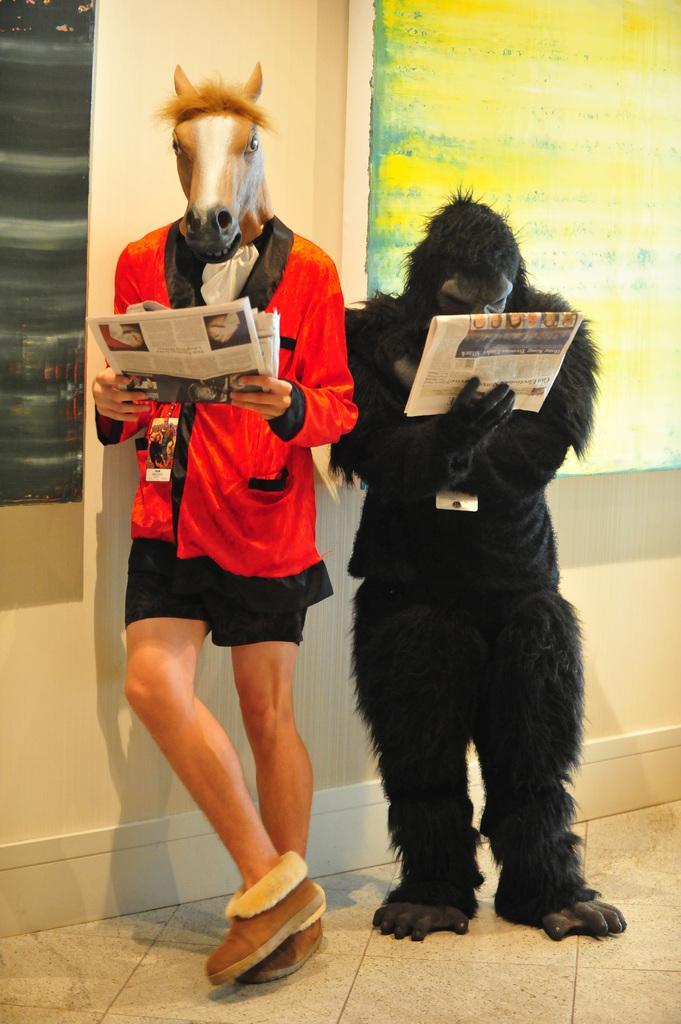In one or two sentences, can you explain what this image depicts? In the center of the image there are two persons wearing mask and holding newspapers in their hand. In the background of the image there is wall. 